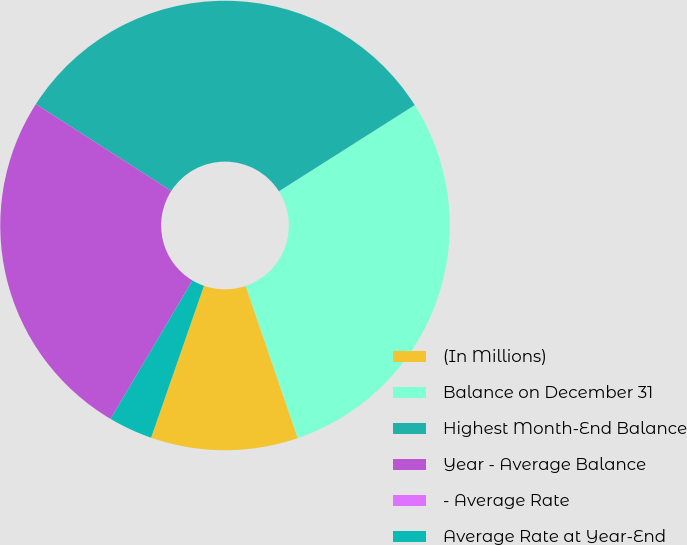Convert chart. <chart><loc_0><loc_0><loc_500><loc_500><pie_chart><fcel>(In Millions)<fcel>Balance on December 31<fcel>Highest Month-End Balance<fcel>Year - Average Balance<fcel>- Average Rate<fcel>Average Rate at Year-End<nl><fcel>10.58%<fcel>28.75%<fcel>31.92%<fcel>25.58%<fcel>0.0%<fcel>3.17%<nl></chart> 